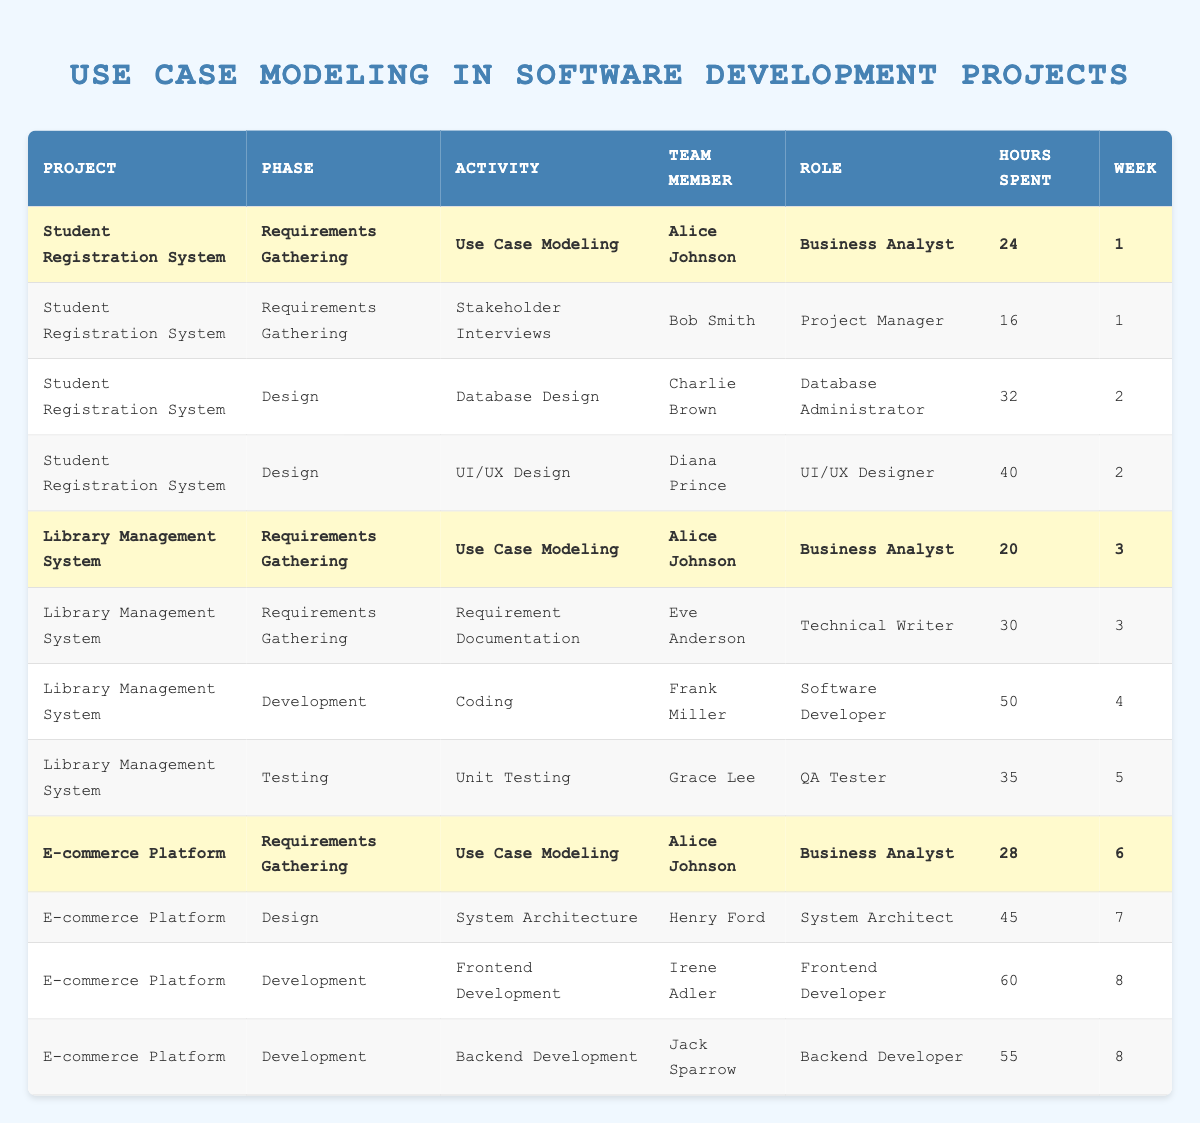What activity did Alice Johnson perform in the Student Registration System? Alice Johnson performed "Use Case Modeling" in the Requirements Gathering phase of the Student Registration System.
Answer: Use Case Modeling How many hours did Diana Prince spend on UI/UX Design? Diana Prince spent 40 hours on the UI/UX Design activity, as indicated in the table under the design phase of the Student Registration System.
Answer: 40 What is the total number of hours spent on Use Case Modeling across all projects? Summing up the hours for Use Case Modeling: 24 (Student Registration) + 20 (Library Management) + 28 (E-commerce Platform) equals 72 hours spent in total.
Answer: 72 Did Grace Lee participate in any Requirements Gathering activities? No, Grace Lee did not participate in any Requirements Gathering activities; her only role is in the Testing phase (Unit Testing), as reflected in the table.
Answer: No Which project required the most hours for the Development phase and what is that total? The E-commerce Platform required the most hours in the Development phase: Frontend Development (60 hours) + Backend Development (55 hours), which gives a total of 115 hours for Development in this project.
Answer: 115 Who spent the least number of hours on Use Case Modeling across all projects? Alice Johnson spent 20 hours on Use Case Modeling in the Library Management System, which is less than the 24 hours she spent on the same activity in the Student Registration System and 28 hours in the E-commerce Platform.
Answer: 20 What role had the highest total hours spent on activities across all projects? The role of Software Developer, represented by Frank Miller in the Library Management System (50 hours), and Irene Adler in the E-commerce Platform (60 hours), led to the highest combined total of 110 hours, making it the role with the most time spent.
Answer: Software Developer Calculate the average hours spent on activities in the Design phase. There are 3 entries for the Design phase: 32 hours (Database Design) + 40 hours (UI/UX Design) + 45 hours (System Architecture) which sums to 117 hours. Dividing by the 3 activities gives an average of 39 hours spent on Design.
Answer: 39 Was there any activity in the Testing phase that spent more than 35 hours? Yes, the only Testing phase activity listed, "Unit Testing" by Grace Lee, took 35 hours, which is not more than 35 but exactly equal to it. Therefore, no activities spent more than 35 hours.
Answer: No 